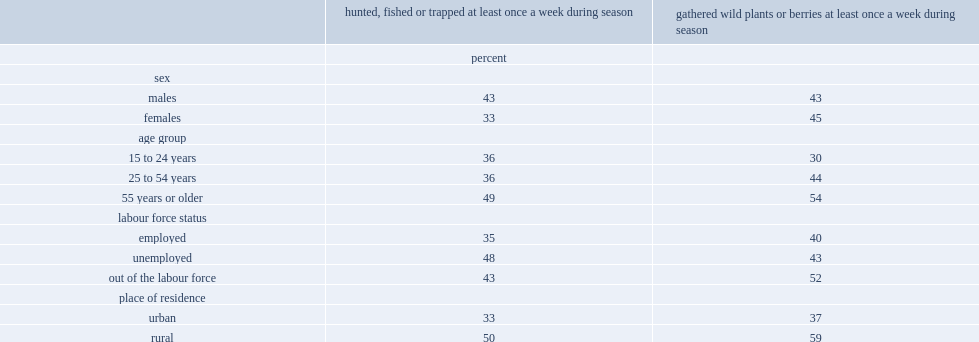Which age group was significantly more likely to hunt, fish or trap at a higher frequency, youth and young adults or older adults? 55 years or older. Which age group was significantly more likely to hunt, fish or trap at a higher frequency, core working-age adults or older adults? 55 years or older. Which age group was significantly more likely to hunt, fish or trap at a higher frequency, unemployed or employed individuals? Unemployed. Which age group was significantly more likely to hunt, fish or trap at a higher frequency, out-of-the-labour-force or employed individuals? Out of the labour force. 